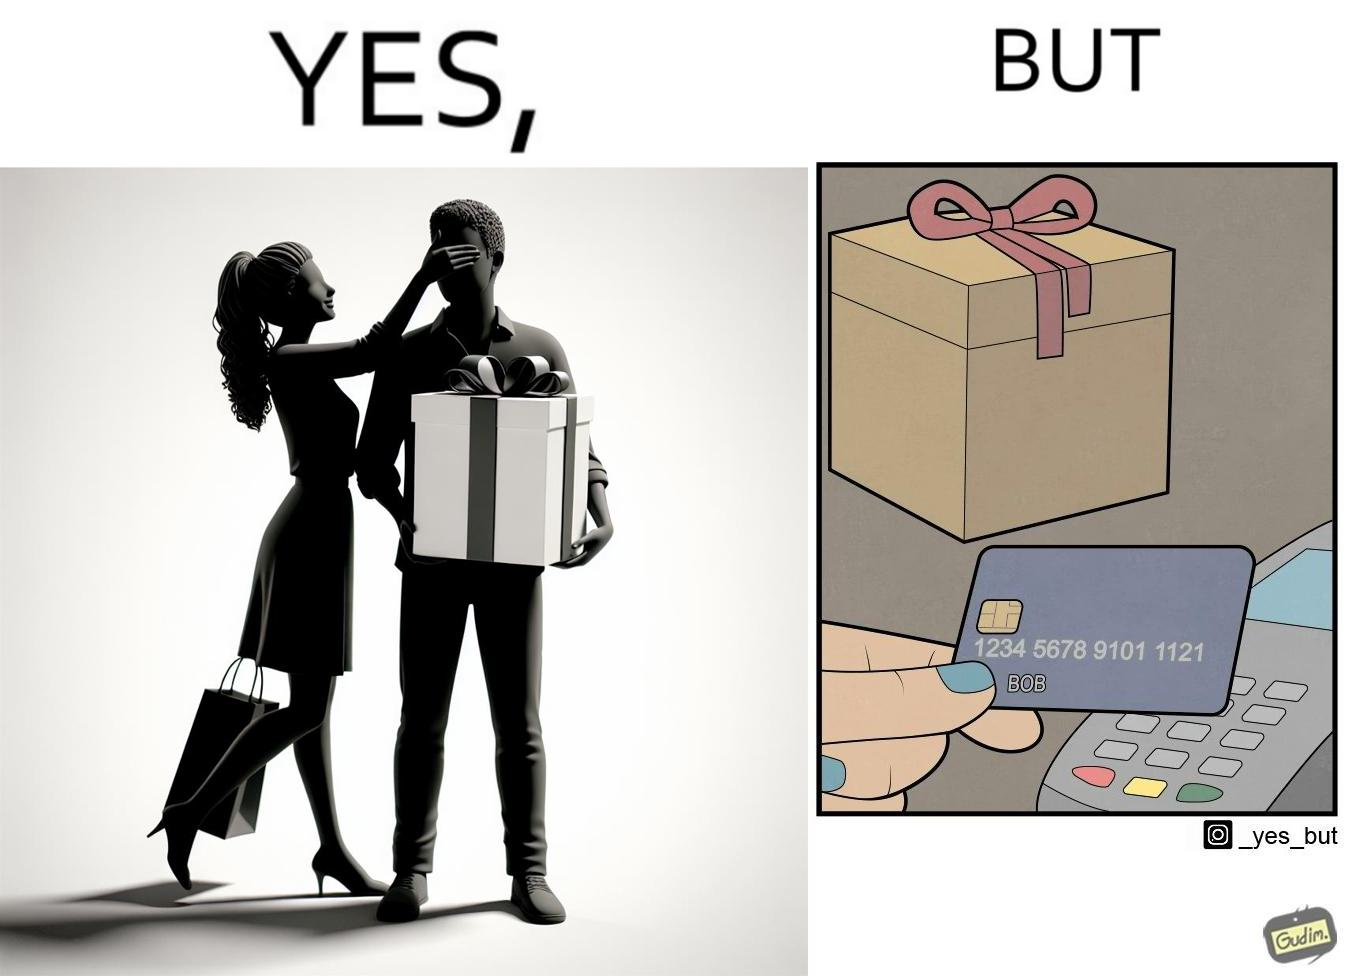What do you see in each half of this image? In the left part of the image: A woman covers the eyes of a man named Bob, while gifting something to him. In the right part of the image: Someone is holding a credit/debit card near a card machine, which has been used to buy the gift that can be seen placed near the card machine. 